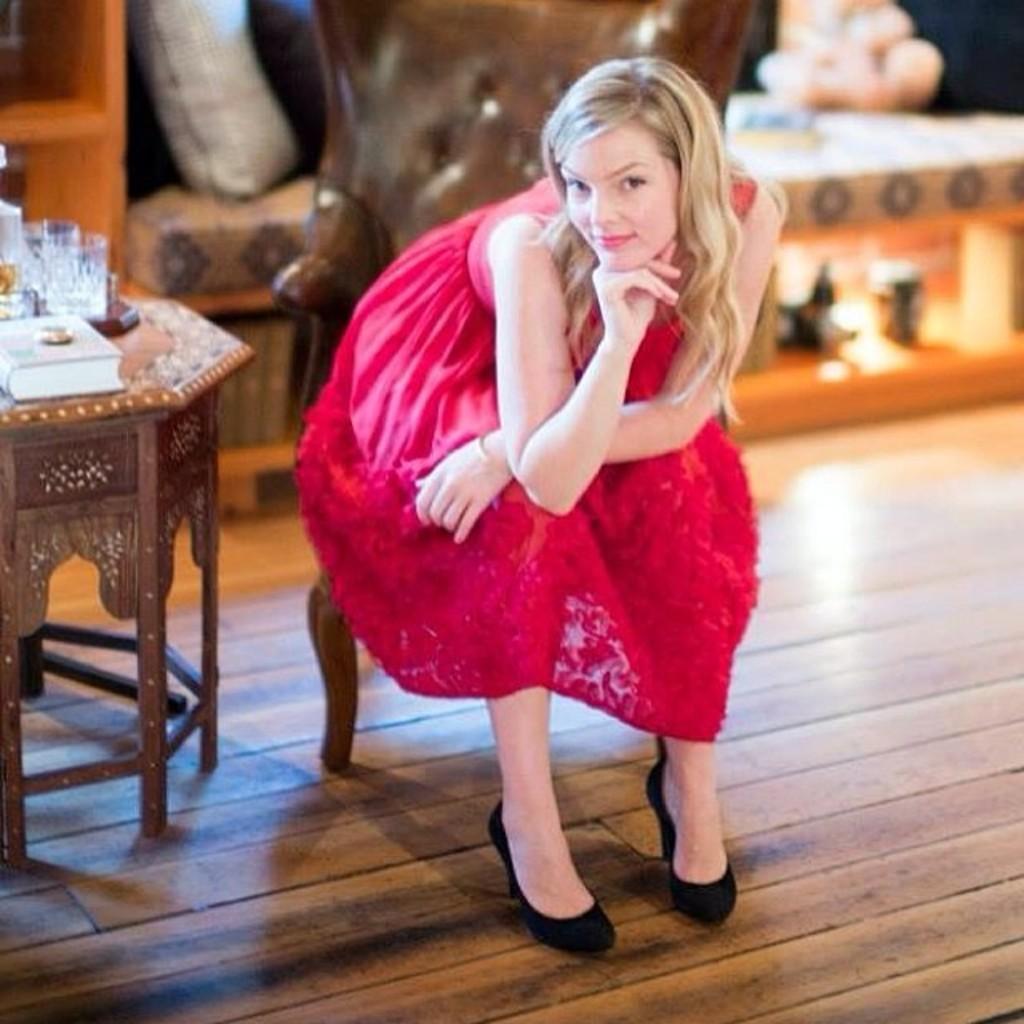Please provide a concise description of this image. In this picture there is a girl sitting on the chair. There is a glass and book on the table. 